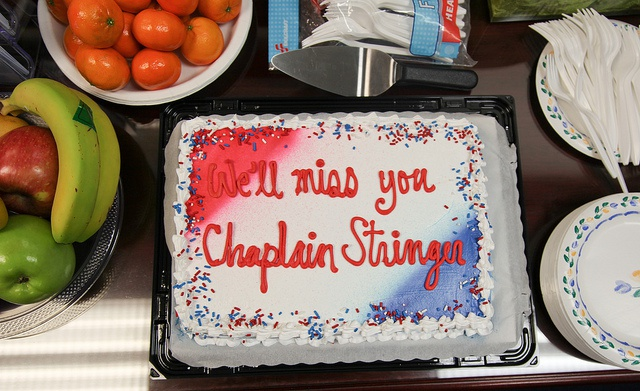Describe the objects in this image and their specific colors. I can see dining table in black, lightgray, and darkgray tones, cake in black, lightgray, darkgray, red, and lightpink tones, bowl in black, red, brown, maroon, and darkgray tones, banana in black and olive tones, and knife in black, gray, and ivory tones in this image. 